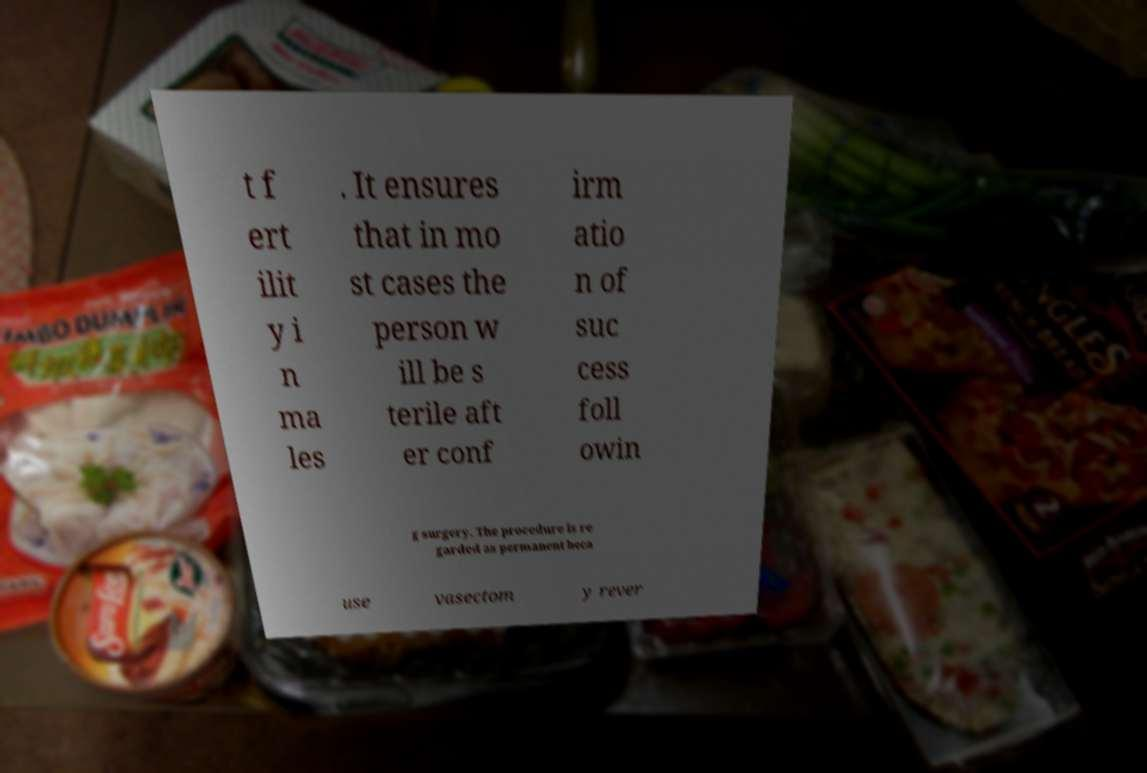Could you extract and type out the text from this image? t f ert ilit y i n ma les . It ensures that in mo st cases the person w ill be s terile aft er conf irm atio n of suc cess foll owin g surgery. The procedure is re garded as permanent beca use vasectom y rever 